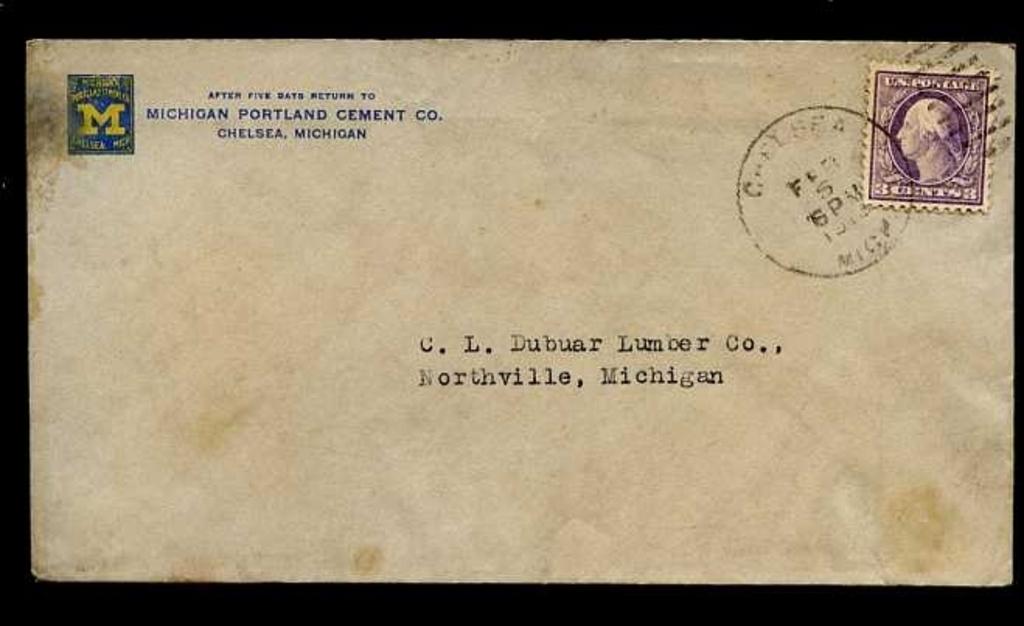What state was this sent from?
Provide a short and direct response. Michigan. What town is the letter going to?
Your answer should be very brief. Northville. 